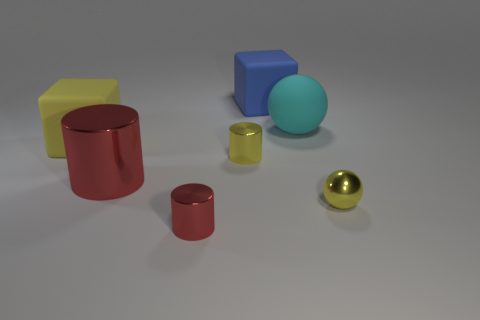Add 2 cyan matte things. How many objects exist? 9 Subtract all small yellow cylinders. How many cylinders are left? 2 Subtract all yellow cylinders. How many cylinders are left? 2 Subtract 2 cylinders. How many cylinders are left? 1 Add 2 tiny shiny spheres. How many tiny shiny spheres are left? 3 Add 6 big brown rubber balls. How many big brown rubber balls exist? 6 Subtract 0 blue balls. How many objects are left? 7 Subtract all cylinders. How many objects are left? 4 Subtract all blue cylinders. Subtract all gray cubes. How many cylinders are left? 3 Subtract all green blocks. How many yellow balls are left? 1 